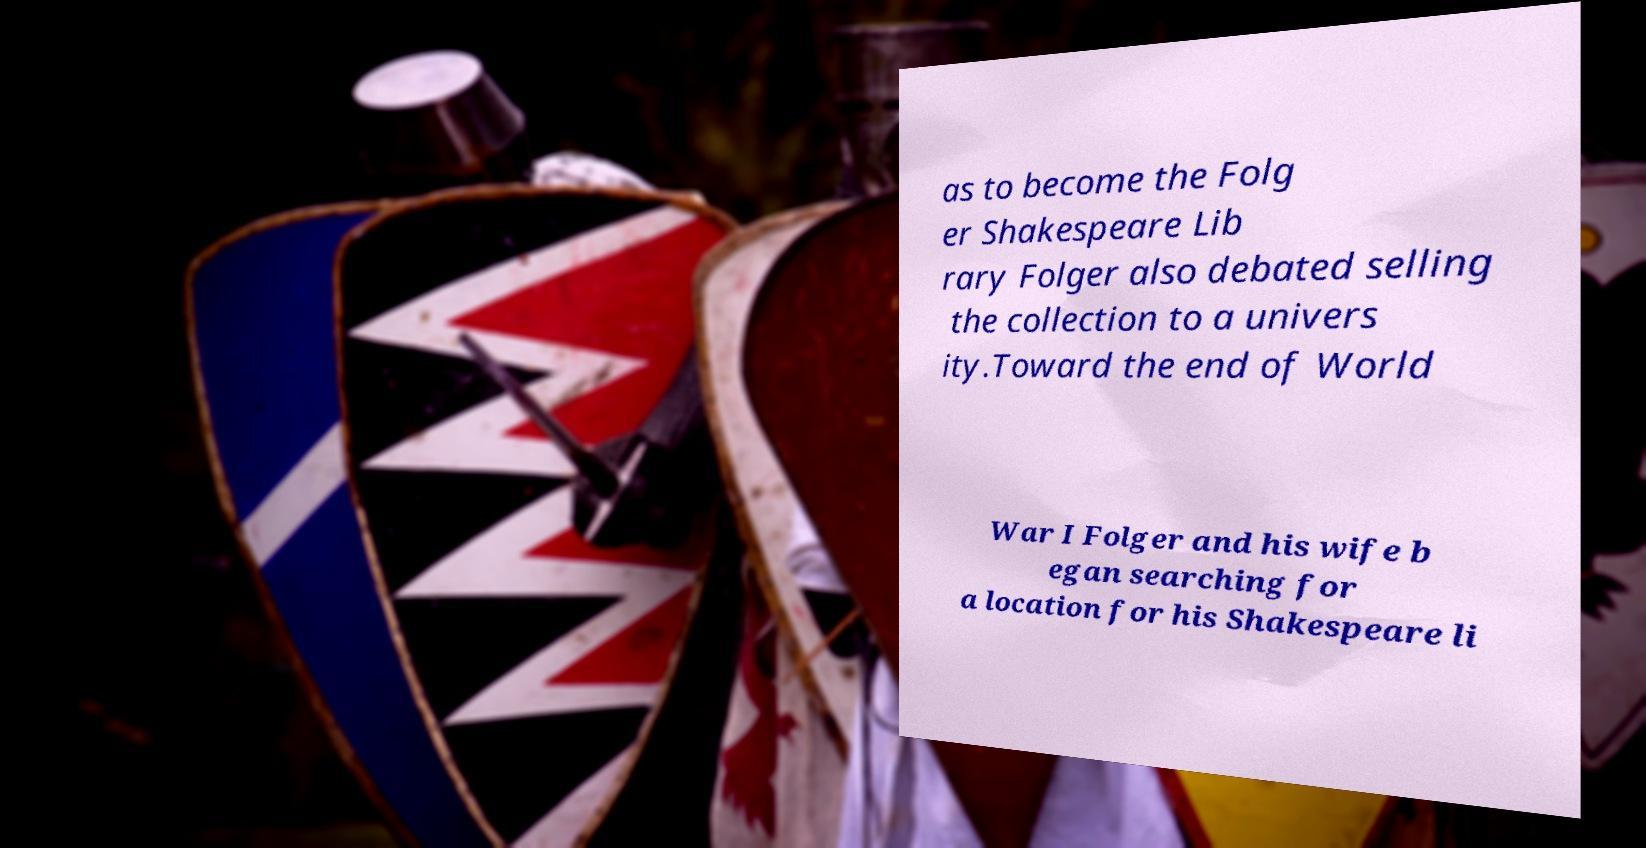Could you assist in decoding the text presented in this image and type it out clearly? as to become the Folg er Shakespeare Lib rary Folger also debated selling the collection to a univers ity.Toward the end of World War I Folger and his wife b egan searching for a location for his Shakespeare li 